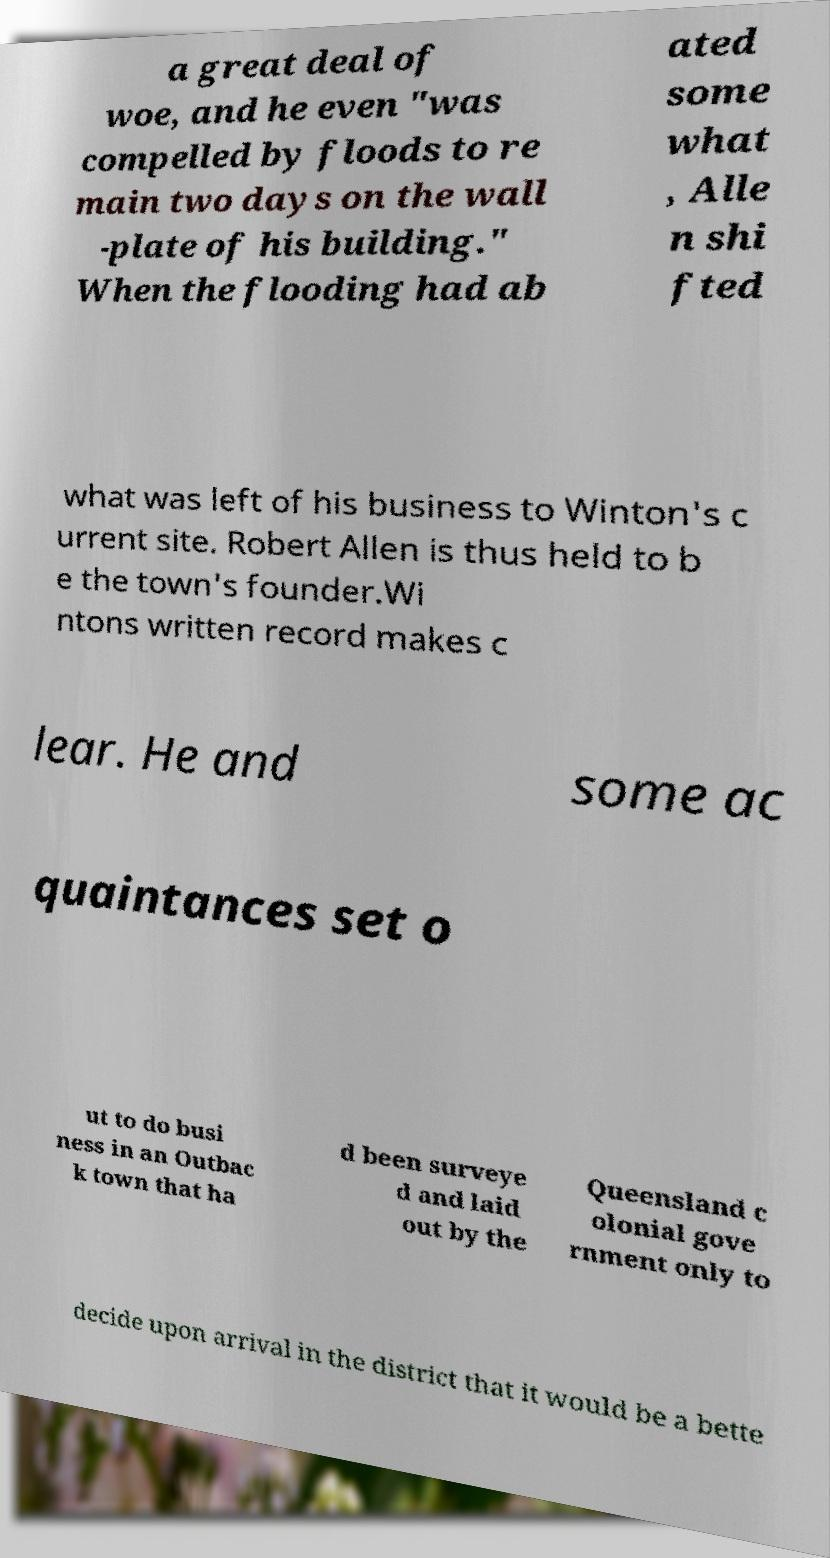Could you extract and type out the text from this image? a great deal of woe, and he even "was compelled by floods to re main two days on the wall -plate of his building." When the flooding had ab ated some what , Alle n shi fted what was left of his business to Winton's c urrent site. Robert Allen is thus held to b e the town's founder.Wi ntons written record makes c lear. He and some ac quaintances set o ut to do busi ness in an Outbac k town that ha d been surveye d and laid out by the Queensland c olonial gove rnment only to decide upon arrival in the district that it would be a bette 